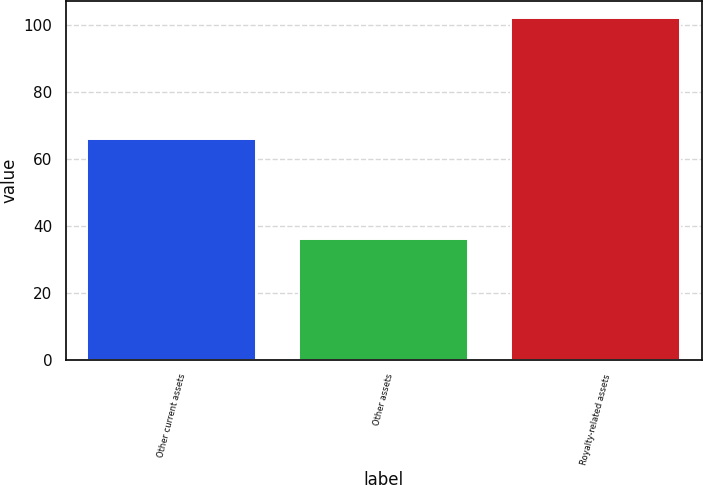<chart> <loc_0><loc_0><loc_500><loc_500><bar_chart><fcel>Other current assets<fcel>Other assets<fcel>Royalty-related assets<nl><fcel>66<fcel>36<fcel>102<nl></chart> 